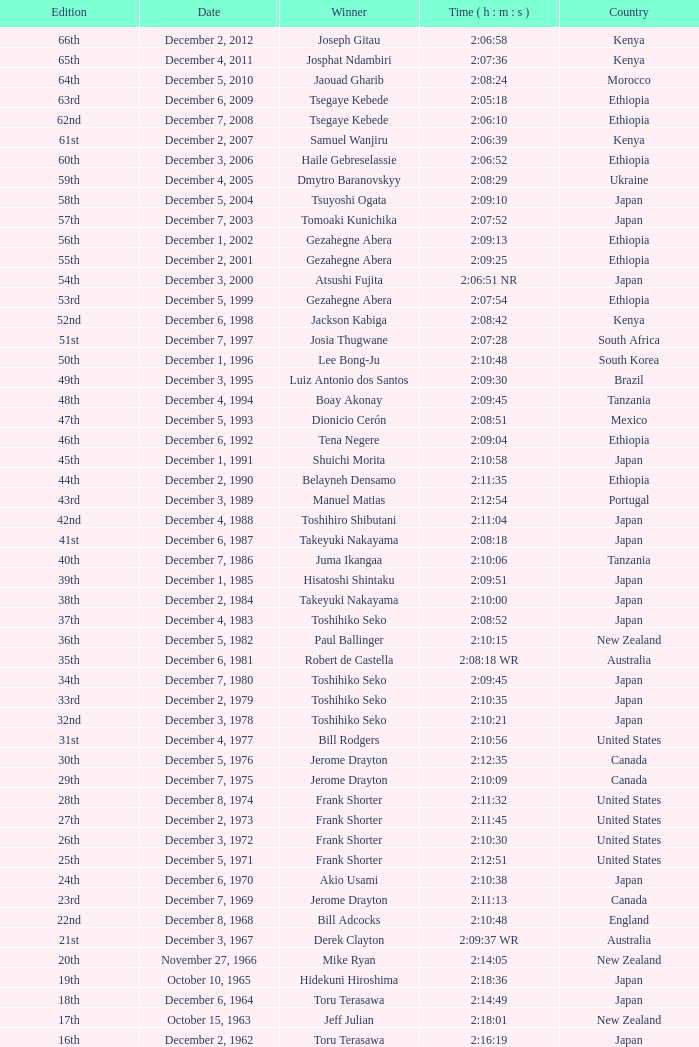What was the nationality of the winner of the 42nd Edition? Japan. 